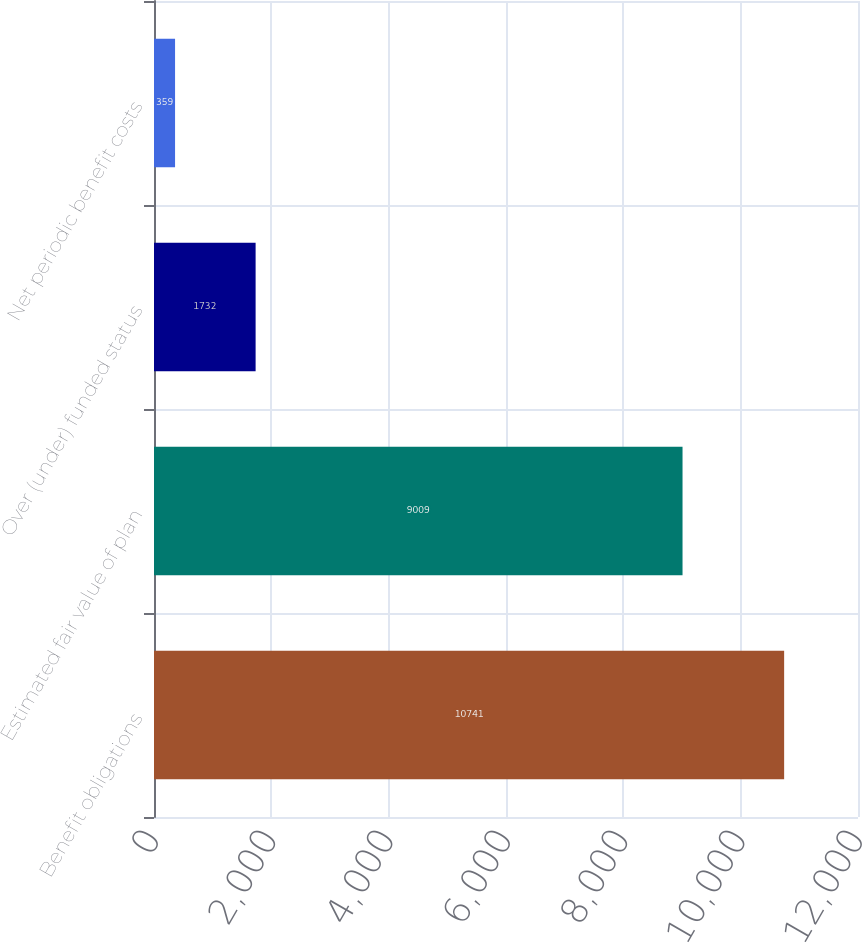<chart> <loc_0><loc_0><loc_500><loc_500><bar_chart><fcel>Benefit obligations<fcel>Estimated fair value of plan<fcel>Over (under) funded status<fcel>Net periodic benefit costs<nl><fcel>10741<fcel>9009<fcel>1732<fcel>359<nl></chart> 